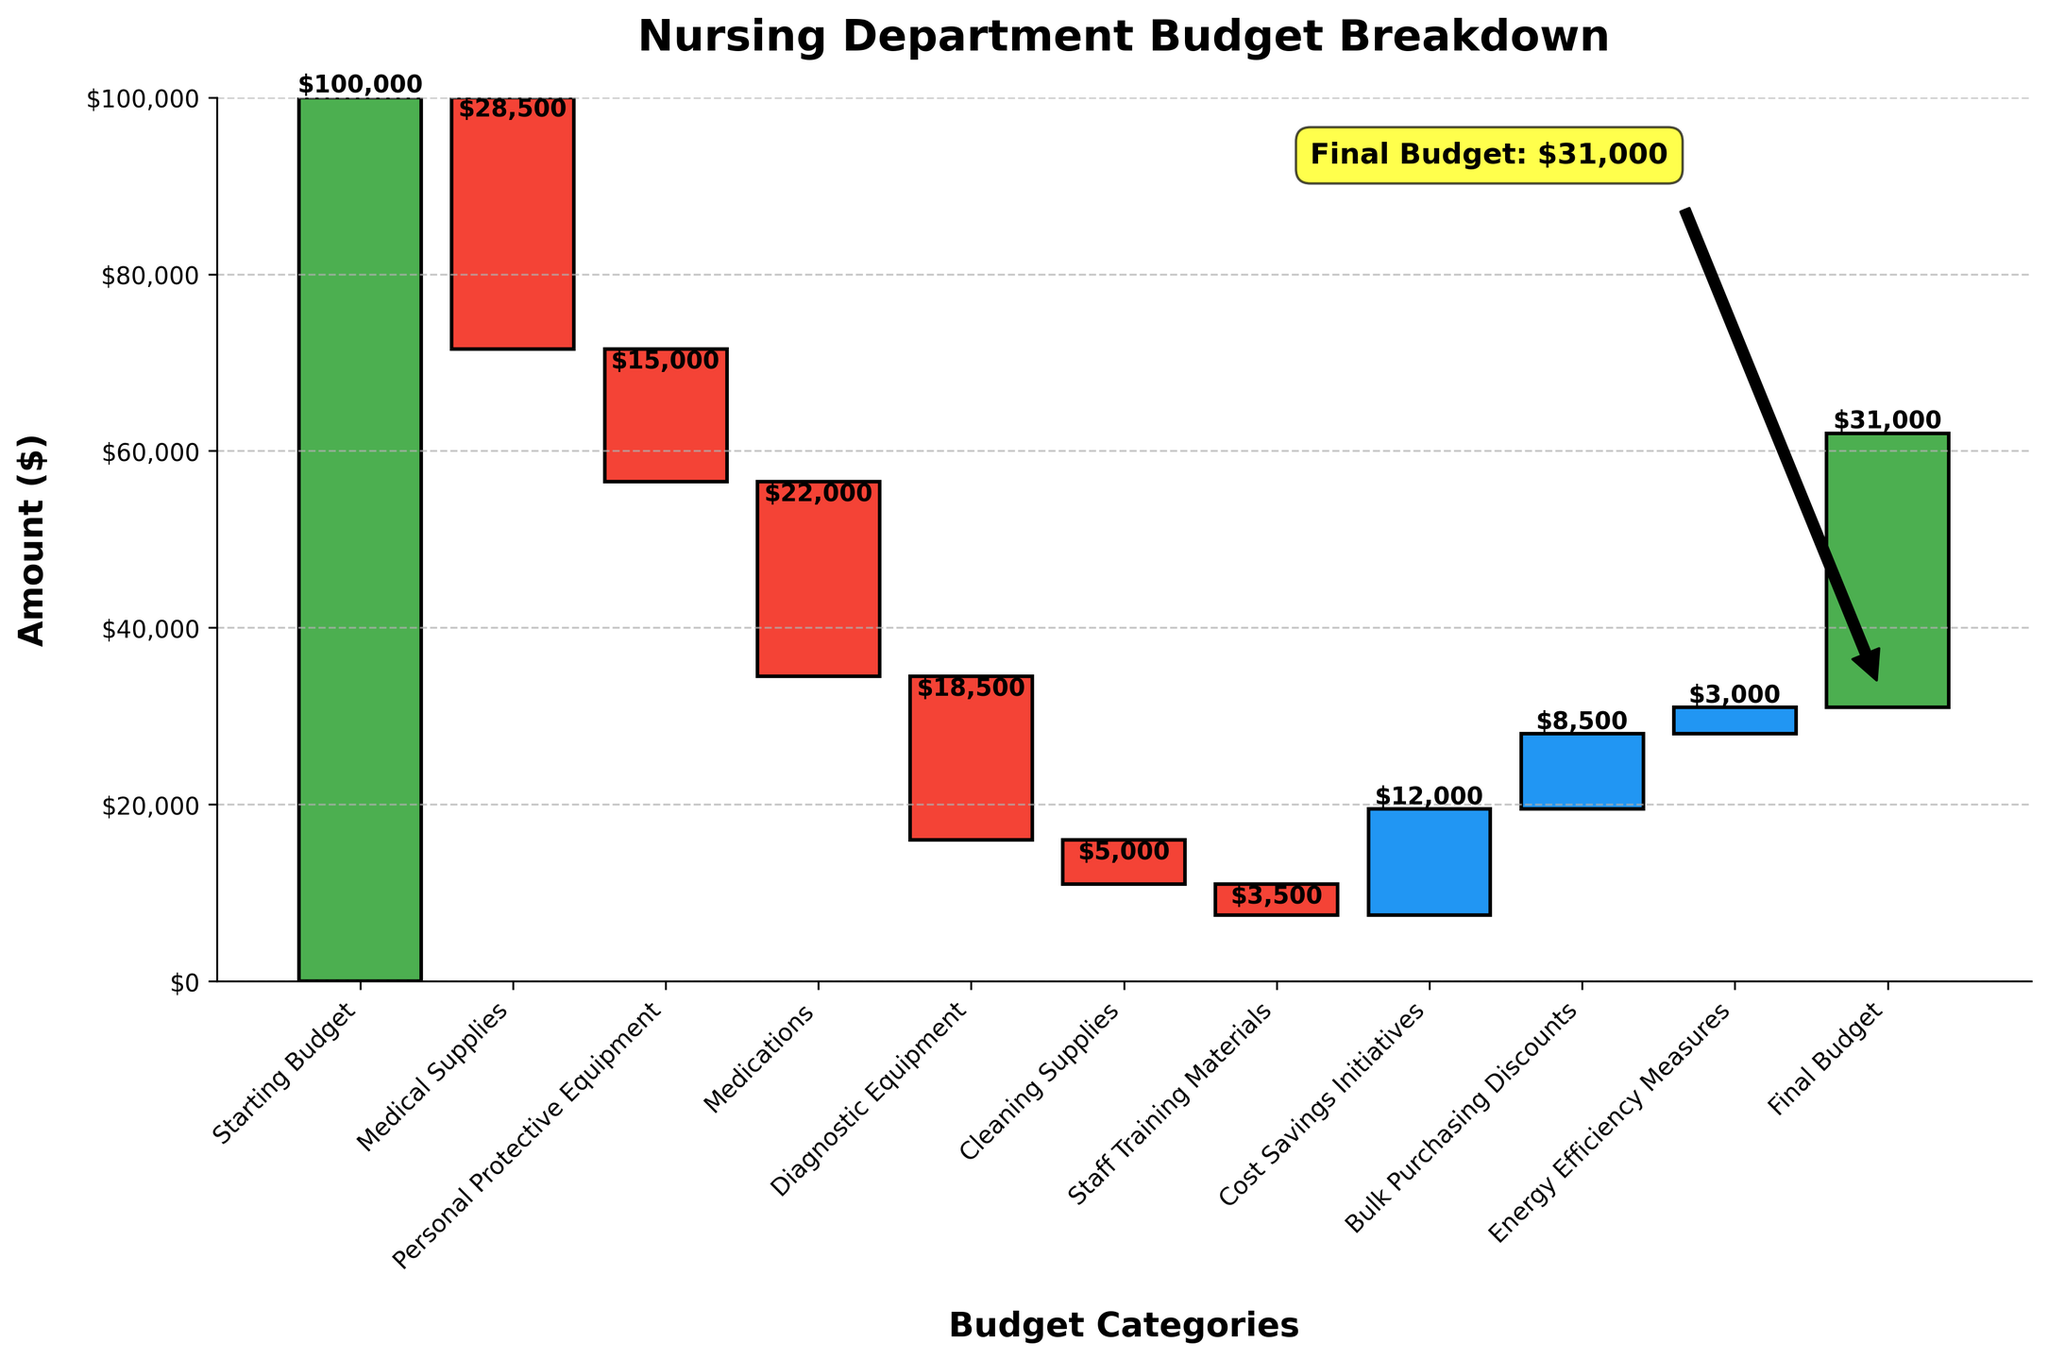What is the title of the chart? The title of the chart is written at the top and it summarizes the content of the chart. In this case, the title is "Nursing Department Budget Breakdown".
Answer: Nursing Department Budget Breakdown What amount is allocated for Medical Supplies? The value for Medical Supplies is shown in the relevant bar in the chart. We can see the value at the top of the bar labeled "Medical Supplies".
Answer: $28,500 How much is the Final Budget? The Final Budget is the last data point on the chart and is shown in a green bar at the end. The exact value for the Final Budget is annotated on the chart.
Answer: $31,000 What are the categories with positive values? The categories with positive values will have bars that extend upwards. We need to identify them by the color blue as indicated in the data preparation process.
Answer: Cost Savings Initiatives, Bulk Purchasing Discounts, Energy Efficiency Measures What is the combined total initial spending on Medical Supplies, PPE, and Medications? Adding the negative values for Medical Supplies, Personal Protective Equipment, and Medications gives us the total initial spending. $28,500 + $15,000 + $22,000 = $65,500.
Answer: $65,500 Which category led to the highest single savings? To find this, we identify the largest positive value from the blue bars which represent savings. The highest one is the "Cost Savings Initiatives".
Answer: Cost Savings Initiatives How much was saved through Energy Efficiency Measures? The chart shows the value for Energy Efficiency Measures in the relevant blue bar. We look at the number displayed for this category.
Answer: $3,000 What is the percentage decrease in budget for Diagnostic Equipment compared to Medical Supplies? First, we find the values for Diagnostic Equipment ($18,500) and Medical Supplies ($28,500). Then calculate the percentage decrease: $18,500 / $28,500 * 100% ≈ 64.9%.
Answer: 64.9% By how much did the Cost Savings Initiatives and Bulk Purchasing Discounts combined impact the budget positively? Adding the positive values from Cost Savings Initiatives and Bulk Purchasing Discounts: $12,000 + $8,500 = $20,500.
Answer: $20,500 What values contributed to the final budget to be $31,000? Starting with the initial budget of $100,000, we add the positive and subtract the negative contributions: $100,000 - $28,500 - $15,000 - $22,000 - $18,500 - $5,000 - $3,500 + $12,000 + $8,500 + $3,000 = $31,000.
Answer: $31,000 